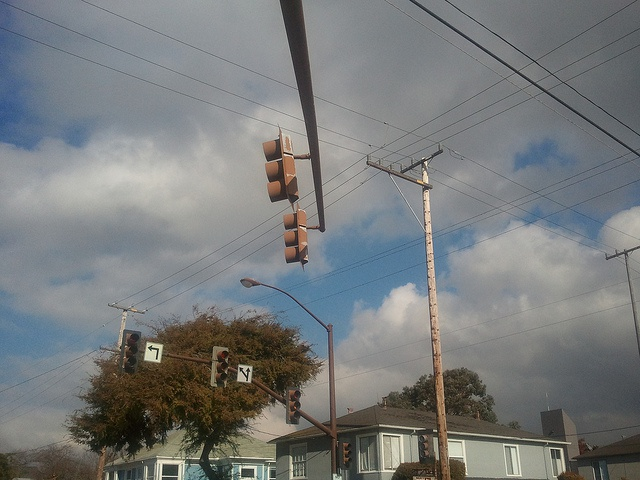Describe the objects in this image and their specific colors. I can see traffic light in blue, gray, black, and maroon tones, traffic light in blue, gray, and black tones, traffic light in blue, black, and gray tones, traffic light in blue, black, gray, and maroon tones, and traffic light in blue, black, gray, and maroon tones in this image. 